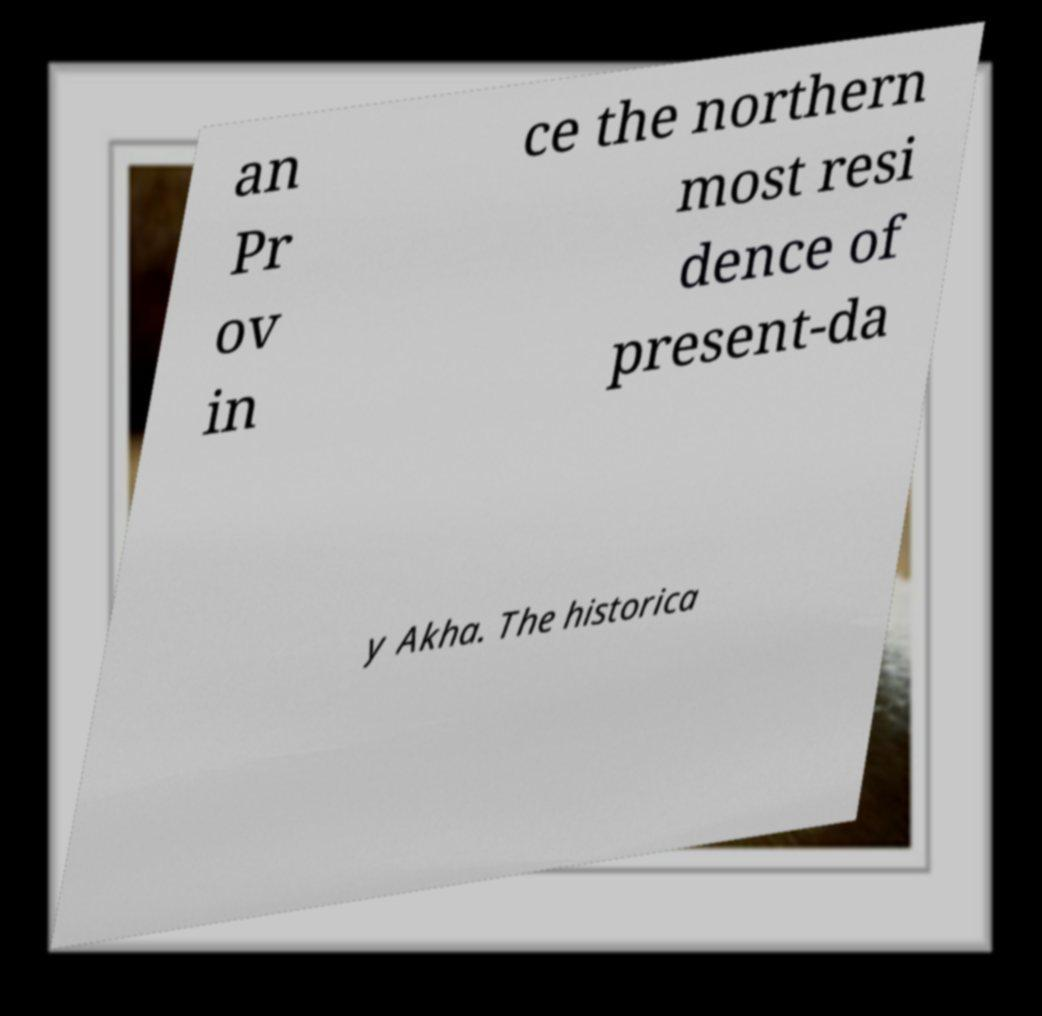Please read and relay the text visible in this image. What does it say? an Pr ov in ce the northern most resi dence of present-da y Akha. The historica 